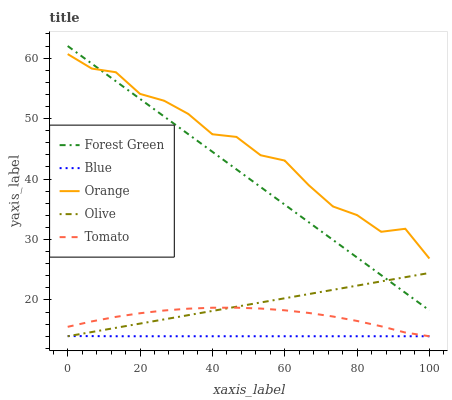Does Blue have the minimum area under the curve?
Answer yes or no. Yes. Does Orange have the maximum area under the curve?
Answer yes or no. Yes. Does Forest Green have the minimum area under the curve?
Answer yes or no. No. Does Forest Green have the maximum area under the curve?
Answer yes or no. No. Is Olive the smoothest?
Answer yes or no. Yes. Is Orange the roughest?
Answer yes or no. Yes. Is Forest Green the smoothest?
Answer yes or no. No. Is Forest Green the roughest?
Answer yes or no. No. Does Blue have the lowest value?
Answer yes or no. Yes. Does Forest Green have the lowest value?
Answer yes or no. No. Does Forest Green have the highest value?
Answer yes or no. Yes. Does Orange have the highest value?
Answer yes or no. No. Is Blue less than Orange?
Answer yes or no. Yes. Is Forest Green greater than Blue?
Answer yes or no. Yes. Does Olive intersect Blue?
Answer yes or no. Yes. Is Olive less than Blue?
Answer yes or no. No. Is Olive greater than Blue?
Answer yes or no. No. Does Blue intersect Orange?
Answer yes or no. No. 